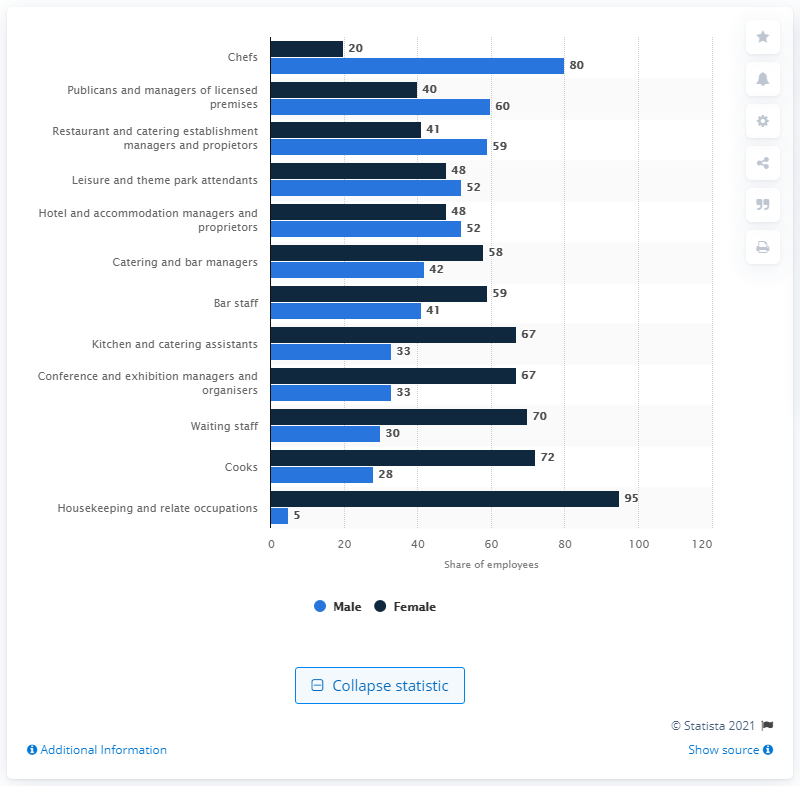Draw attention to some important aspects in this diagram. In 2011, 52% of hotel and accommodation managers and proprietors were male. The sum of the two highest bars in the chart is 175. The highest value in the dark blue bar is 95. In 2011, approximately 48% of hotel and accommodation managers and proprietors were female. 